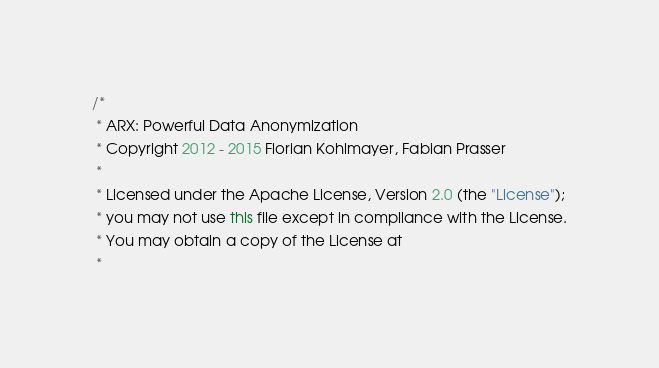<code> <loc_0><loc_0><loc_500><loc_500><_Java_>/*
 * ARX: Powerful Data Anonymization
 * Copyright 2012 - 2015 Florian Kohlmayer, Fabian Prasser
 * 
 * Licensed under the Apache License, Version 2.0 (the "License");
 * you may not use this file except in compliance with the License.
 * You may obtain a copy of the License at
 * </code> 